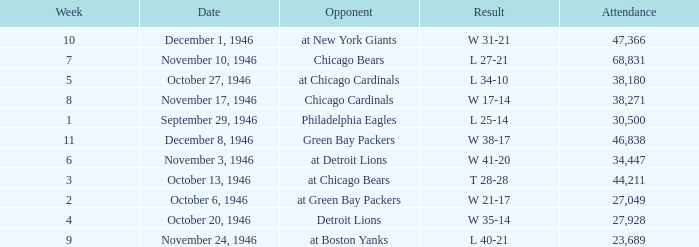What is the combined attendance of all games that had a result of w 35-14? 27928.0. Parse the table in full. {'header': ['Week', 'Date', 'Opponent', 'Result', 'Attendance'], 'rows': [['10', 'December 1, 1946', 'at New York Giants', 'W 31-21', '47,366'], ['7', 'November 10, 1946', 'Chicago Bears', 'L 27-21', '68,831'], ['5', 'October 27, 1946', 'at Chicago Cardinals', 'L 34-10', '38,180'], ['8', 'November 17, 1946', 'Chicago Cardinals', 'W 17-14', '38,271'], ['1', 'September 29, 1946', 'Philadelphia Eagles', 'L 25-14', '30,500'], ['11', 'December 8, 1946', 'Green Bay Packers', 'W 38-17', '46,838'], ['6', 'November 3, 1946', 'at Detroit Lions', 'W 41-20', '34,447'], ['3', 'October 13, 1946', 'at Chicago Bears', 'T 28-28', '44,211'], ['2', 'October 6, 1946', 'at Green Bay Packers', 'W 21-17', '27,049'], ['4', 'October 20, 1946', 'Detroit Lions', 'W 35-14', '27,928'], ['9', 'November 24, 1946', 'at Boston Yanks', 'L 40-21', '23,689']]} 